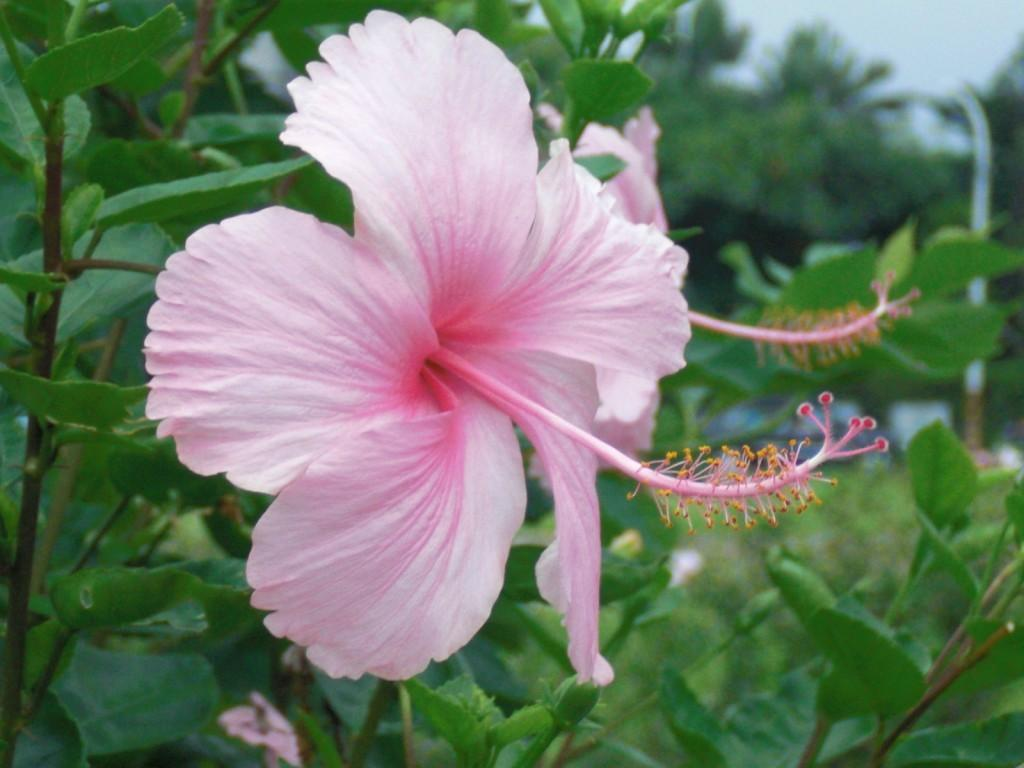What is the main subject of the image? There is a flower in the image. What can be seen in the background of the image? There are trees in the background of the image. What part of the queen's dress can be seen in the image? There is no queen or dress present in the image; it features a flower and trees in the background. 